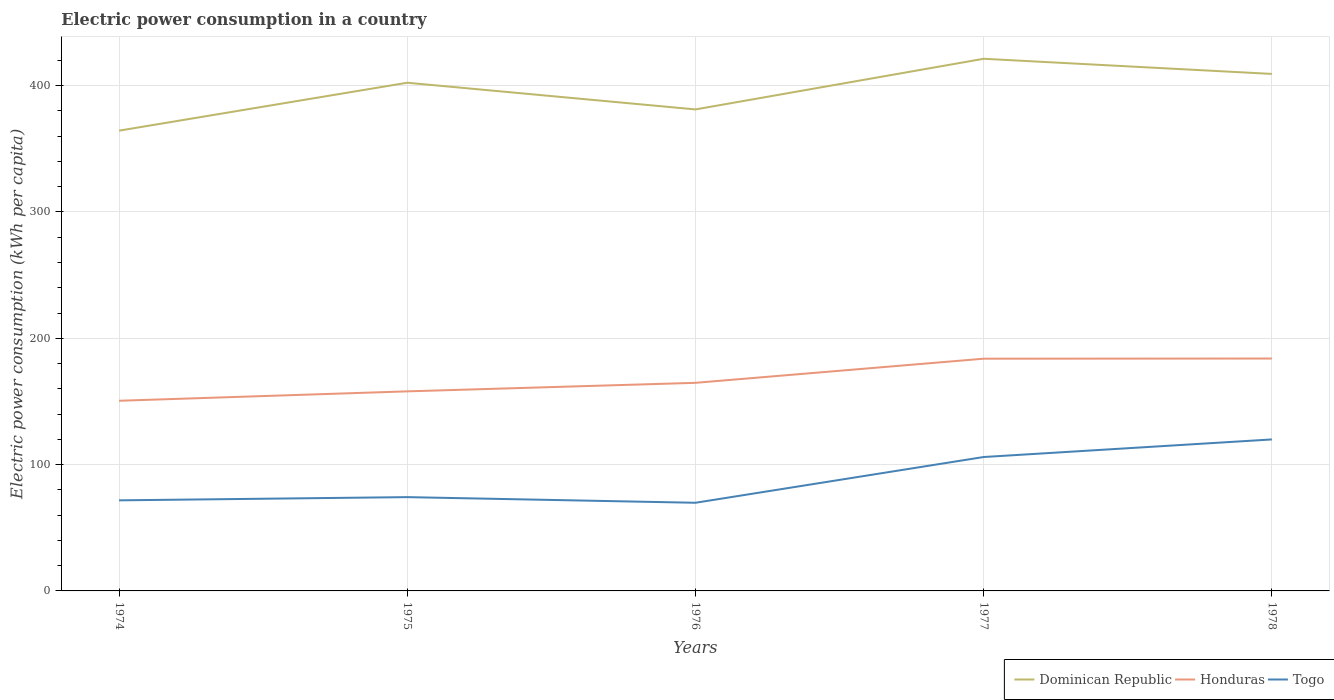How many different coloured lines are there?
Keep it short and to the point. 3. Does the line corresponding to Togo intersect with the line corresponding to Honduras?
Provide a short and direct response. No. Across all years, what is the maximum electric power consumption in in Honduras?
Ensure brevity in your answer.  150.55. In which year was the electric power consumption in in Dominican Republic maximum?
Provide a short and direct response. 1974. What is the total electric power consumption in in Honduras in the graph?
Your response must be concise. -7.44. What is the difference between the highest and the second highest electric power consumption in in Dominican Republic?
Keep it short and to the point. 56.92. How many lines are there?
Provide a succinct answer. 3. How many years are there in the graph?
Your response must be concise. 5. What is the difference between two consecutive major ticks on the Y-axis?
Offer a very short reply. 100. Does the graph contain any zero values?
Ensure brevity in your answer.  No. Does the graph contain grids?
Provide a short and direct response. Yes. How are the legend labels stacked?
Offer a terse response. Horizontal. What is the title of the graph?
Make the answer very short. Electric power consumption in a country. What is the label or title of the Y-axis?
Make the answer very short. Electric power consumption (kWh per capita). What is the Electric power consumption (kWh per capita) of Dominican Republic in 1974?
Your answer should be very brief. 364.38. What is the Electric power consumption (kWh per capita) of Honduras in 1974?
Provide a succinct answer. 150.55. What is the Electric power consumption (kWh per capita) in Togo in 1974?
Make the answer very short. 71.71. What is the Electric power consumption (kWh per capita) in Dominican Republic in 1975?
Provide a short and direct response. 402.34. What is the Electric power consumption (kWh per capita) of Honduras in 1975?
Ensure brevity in your answer.  157.99. What is the Electric power consumption (kWh per capita) in Togo in 1975?
Offer a very short reply. 74.26. What is the Electric power consumption (kWh per capita) of Dominican Republic in 1976?
Give a very brief answer. 381.2. What is the Electric power consumption (kWh per capita) in Honduras in 1976?
Make the answer very short. 164.75. What is the Electric power consumption (kWh per capita) of Togo in 1976?
Provide a succinct answer. 69.79. What is the Electric power consumption (kWh per capita) of Dominican Republic in 1977?
Offer a terse response. 421.3. What is the Electric power consumption (kWh per capita) in Honduras in 1977?
Give a very brief answer. 183.85. What is the Electric power consumption (kWh per capita) in Togo in 1977?
Provide a succinct answer. 106.01. What is the Electric power consumption (kWh per capita) of Dominican Republic in 1978?
Make the answer very short. 409.31. What is the Electric power consumption (kWh per capita) in Honduras in 1978?
Give a very brief answer. 183.98. What is the Electric power consumption (kWh per capita) of Togo in 1978?
Offer a very short reply. 119.93. Across all years, what is the maximum Electric power consumption (kWh per capita) in Dominican Republic?
Provide a succinct answer. 421.3. Across all years, what is the maximum Electric power consumption (kWh per capita) in Honduras?
Your answer should be compact. 183.98. Across all years, what is the maximum Electric power consumption (kWh per capita) in Togo?
Offer a very short reply. 119.93. Across all years, what is the minimum Electric power consumption (kWh per capita) in Dominican Republic?
Give a very brief answer. 364.38. Across all years, what is the minimum Electric power consumption (kWh per capita) of Honduras?
Offer a terse response. 150.55. Across all years, what is the minimum Electric power consumption (kWh per capita) of Togo?
Give a very brief answer. 69.79. What is the total Electric power consumption (kWh per capita) of Dominican Republic in the graph?
Offer a very short reply. 1978.52. What is the total Electric power consumption (kWh per capita) of Honduras in the graph?
Your answer should be compact. 841.12. What is the total Electric power consumption (kWh per capita) of Togo in the graph?
Keep it short and to the point. 441.71. What is the difference between the Electric power consumption (kWh per capita) of Dominican Republic in 1974 and that in 1975?
Make the answer very short. -37.95. What is the difference between the Electric power consumption (kWh per capita) in Honduras in 1974 and that in 1975?
Keep it short and to the point. -7.44. What is the difference between the Electric power consumption (kWh per capita) of Togo in 1974 and that in 1975?
Provide a short and direct response. -2.55. What is the difference between the Electric power consumption (kWh per capita) in Dominican Republic in 1974 and that in 1976?
Offer a terse response. -16.82. What is the difference between the Electric power consumption (kWh per capita) in Honduras in 1974 and that in 1976?
Offer a terse response. -14.2. What is the difference between the Electric power consumption (kWh per capita) of Togo in 1974 and that in 1976?
Give a very brief answer. 1.92. What is the difference between the Electric power consumption (kWh per capita) of Dominican Republic in 1974 and that in 1977?
Offer a very short reply. -56.92. What is the difference between the Electric power consumption (kWh per capita) in Honduras in 1974 and that in 1977?
Give a very brief answer. -33.3. What is the difference between the Electric power consumption (kWh per capita) in Togo in 1974 and that in 1977?
Make the answer very short. -34.3. What is the difference between the Electric power consumption (kWh per capita) in Dominican Republic in 1974 and that in 1978?
Your response must be concise. -44.93. What is the difference between the Electric power consumption (kWh per capita) of Honduras in 1974 and that in 1978?
Your response must be concise. -33.43. What is the difference between the Electric power consumption (kWh per capita) in Togo in 1974 and that in 1978?
Give a very brief answer. -48.22. What is the difference between the Electric power consumption (kWh per capita) of Dominican Republic in 1975 and that in 1976?
Your response must be concise. 21.14. What is the difference between the Electric power consumption (kWh per capita) in Honduras in 1975 and that in 1976?
Give a very brief answer. -6.76. What is the difference between the Electric power consumption (kWh per capita) in Togo in 1975 and that in 1976?
Offer a very short reply. 4.47. What is the difference between the Electric power consumption (kWh per capita) in Dominican Republic in 1975 and that in 1977?
Provide a succinct answer. -18.96. What is the difference between the Electric power consumption (kWh per capita) in Honduras in 1975 and that in 1977?
Give a very brief answer. -25.86. What is the difference between the Electric power consumption (kWh per capita) in Togo in 1975 and that in 1977?
Keep it short and to the point. -31.75. What is the difference between the Electric power consumption (kWh per capita) of Dominican Republic in 1975 and that in 1978?
Keep it short and to the point. -6.97. What is the difference between the Electric power consumption (kWh per capita) in Honduras in 1975 and that in 1978?
Your answer should be very brief. -25.99. What is the difference between the Electric power consumption (kWh per capita) in Togo in 1975 and that in 1978?
Provide a short and direct response. -45.67. What is the difference between the Electric power consumption (kWh per capita) in Dominican Republic in 1976 and that in 1977?
Make the answer very short. -40.1. What is the difference between the Electric power consumption (kWh per capita) of Honduras in 1976 and that in 1977?
Your answer should be very brief. -19.1. What is the difference between the Electric power consumption (kWh per capita) of Togo in 1976 and that in 1977?
Your answer should be compact. -36.22. What is the difference between the Electric power consumption (kWh per capita) in Dominican Republic in 1976 and that in 1978?
Your response must be concise. -28.11. What is the difference between the Electric power consumption (kWh per capita) in Honduras in 1976 and that in 1978?
Offer a very short reply. -19.23. What is the difference between the Electric power consumption (kWh per capita) in Togo in 1976 and that in 1978?
Offer a very short reply. -50.14. What is the difference between the Electric power consumption (kWh per capita) in Dominican Republic in 1977 and that in 1978?
Offer a terse response. 11.99. What is the difference between the Electric power consumption (kWh per capita) of Honduras in 1977 and that in 1978?
Provide a short and direct response. -0.13. What is the difference between the Electric power consumption (kWh per capita) of Togo in 1977 and that in 1978?
Make the answer very short. -13.92. What is the difference between the Electric power consumption (kWh per capita) of Dominican Republic in 1974 and the Electric power consumption (kWh per capita) of Honduras in 1975?
Your answer should be compact. 206.39. What is the difference between the Electric power consumption (kWh per capita) in Dominican Republic in 1974 and the Electric power consumption (kWh per capita) in Togo in 1975?
Offer a terse response. 290.12. What is the difference between the Electric power consumption (kWh per capita) of Honduras in 1974 and the Electric power consumption (kWh per capita) of Togo in 1975?
Offer a terse response. 76.29. What is the difference between the Electric power consumption (kWh per capita) of Dominican Republic in 1974 and the Electric power consumption (kWh per capita) of Honduras in 1976?
Your response must be concise. 199.63. What is the difference between the Electric power consumption (kWh per capita) of Dominican Republic in 1974 and the Electric power consumption (kWh per capita) of Togo in 1976?
Keep it short and to the point. 294.59. What is the difference between the Electric power consumption (kWh per capita) of Honduras in 1974 and the Electric power consumption (kWh per capita) of Togo in 1976?
Your response must be concise. 80.76. What is the difference between the Electric power consumption (kWh per capita) in Dominican Republic in 1974 and the Electric power consumption (kWh per capita) in Honduras in 1977?
Your answer should be very brief. 180.53. What is the difference between the Electric power consumption (kWh per capita) in Dominican Republic in 1974 and the Electric power consumption (kWh per capita) in Togo in 1977?
Your answer should be very brief. 258.37. What is the difference between the Electric power consumption (kWh per capita) of Honduras in 1974 and the Electric power consumption (kWh per capita) of Togo in 1977?
Your answer should be compact. 44.54. What is the difference between the Electric power consumption (kWh per capita) in Dominican Republic in 1974 and the Electric power consumption (kWh per capita) in Honduras in 1978?
Provide a short and direct response. 180.4. What is the difference between the Electric power consumption (kWh per capita) in Dominican Republic in 1974 and the Electric power consumption (kWh per capita) in Togo in 1978?
Your answer should be compact. 244.45. What is the difference between the Electric power consumption (kWh per capita) in Honduras in 1974 and the Electric power consumption (kWh per capita) in Togo in 1978?
Offer a terse response. 30.62. What is the difference between the Electric power consumption (kWh per capita) of Dominican Republic in 1975 and the Electric power consumption (kWh per capita) of Honduras in 1976?
Your answer should be compact. 237.59. What is the difference between the Electric power consumption (kWh per capita) in Dominican Republic in 1975 and the Electric power consumption (kWh per capita) in Togo in 1976?
Offer a terse response. 332.54. What is the difference between the Electric power consumption (kWh per capita) in Honduras in 1975 and the Electric power consumption (kWh per capita) in Togo in 1976?
Offer a terse response. 88.2. What is the difference between the Electric power consumption (kWh per capita) of Dominican Republic in 1975 and the Electric power consumption (kWh per capita) of Honduras in 1977?
Ensure brevity in your answer.  218.48. What is the difference between the Electric power consumption (kWh per capita) in Dominican Republic in 1975 and the Electric power consumption (kWh per capita) in Togo in 1977?
Give a very brief answer. 296.32. What is the difference between the Electric power consumption (kWh per capita) of Honduras in 1975 and the Electric power consumption (kWh per capita) of Togo in 1977?
Provide a succinct answer. 51.98. What is the difference between the Electric power consumption (kWh per capita) of Dominican Republic in 1975 and the Electric power consumption (kWh per capita) of Honduras in 1978?
Provide a short and direct response. 218.36. What is the difference between the Electric power consumption (kWh per capita) of Dominican Republic in 1975 and the Electric power consumption (kWh per capita) of Togo in 1978?
Provide a succinct answer. 282.4. What is the difference between the Electric power consumption (kWh per capita) in Honduras in 1975 and the Electric power consumption (kWh per capita) in Togo in 1978?
Offer a very short reply. 38.06. What is the difference between the Electric power consumption (kWh per capita) of Dominican Republic in 1976 and the Electric power consumption (kWh per capita) of Honduras in 1977?
Give a very brief answer. 197.34. What is the difference between the Electric power consumption (kWh per capita) of Dominican Republic in 1976 and the Electric power consumption (kWh per capita) of Togo in 1977?
Your answer should be compact. 275.18. What is the difference between the Electric power consumption (kWh per capita) in Honduras in 1976 and the Electric power consumption (kWh per capita) in Togo in 1977?
Offer a terse response. 58.74. What is the difference between the Electric power consumption (kWh per capita) in Dominican Republic in 1976 and the Electric power consumption (kWh per capita) in Honduras in 1978?
Your response must be concise. 197.22. What is the difference between the Electric power consumption (kWh per capita) of Dominican Republic in 1976 and the Electric power consumption (kWh per capita) of Togo in 1978?
Your answer should be compact. 261.27. What is the difference between the Electric power consumption (kWh per capita) in Honduras in 1976 and the Electric power consumption (kWh per capita) in Togo in 1978?
Your answer should be compact. 44.82. What is the difference between the Electric power consumption (kWh per capita) in Dominican Republic in 1977 and the Electric power consumption (kWh per capita) in Honduras in 1978?
Ensure brevity in your answer.  237.32. What is the difference between the Electric power consumption (kWh per capita) of Dominican Republic in 1977 and the Electric power consumption (kWh per capita) of Togo in 1978?
Offer a very short reply. 301.36. What is the difference between the Electric power consumption (kWh per capita) of Honduras in 1977 and the Electric power consumption (kWh per capita) of Togo in 1978?
Ensure brevity in your answer.  63.92. What is the average Electric power consumption (kWh per capita) in Dominican Republic per year?
Provide a succinct answer. 395.7. What is the average Electric power consumption (kWh per capita) of Honduras per year?
Provide a succinct answer. 168.22. What is the average Electric power consumption (kWh per capita) of Togo per year?
Your answer should be very brief. 88.34. In the year 1974, what is the difference between the Electric power consumption (kWh per capita) of Dominican Republic and Electric power consumption (kWh per capita) of Honduras?
Provide a short and direct response. 213.83. In the year 1974, what is the difference between the Electric power consumption (kWh per capita) in Dominican Republic and Electric power consumption (kWh per capita) in Togo?
Provide a short and direct response. 292.67. In the year 1974, what is the difference between the Electric power consumption (kWh per capita) of Honduras and Electric power consumption (kWh per capita) of Togo?
Give a very brief answer. 78.84. In the year 1975, what is the difference between the Electric power consumption (kWh per capita) of Dominican Republic and Electric power consumption (kWh per capita) of Honduras?
Your answer should be very brief. 244.34. In the year 1975, what is the difference between the Electric power consumption (kWh per capita) of Dominican Republic and Electric power consumption (kWh per capita) of Togo?
Ensure brevity in your answer.  328.08. In the year 1975, what is the difference between the Electric power consumption (kWh per capita) in Honduras and Electric power consumption (kWh per capita) in Togo?
Provide a short and direct response. 83.73. In the year 1976, what is the difference between the Electric power consumption (kWh per capita) in Dominican Republic and Electric power consumption (kWh per capita) in Honduras?
Your answer should be compact. 216.45. In the year 1976, what is the difference between the Electric power consumption (kWh per capita) in Dominican Republic and Electric power consumption (kWh per capita) in Togo?
Keep it short and to the point. 311.41. In the year 1976, what is the difference between the Electric power consumption (kWh per capita) of Honduras and Electric power consumption (kWh per capita) of Togo?
Your answer should be compact. 94.96. In the year 1977, what is the difference between the Electric power consumption (kWh per capita) in Dominican Republic and Electric power consumption (kWh per capita) in Honduras?
Keep it short and to the point. 237.44. In the year 1977, what is the difference between the Electric power consumption (kWh per capita) in Dominican Republic and Electric power consumption (kWh per capita) in Togo?
Your answer should be very brief. 315.28. In the year 1977, what is the difference between the Electric power consumption (kWh per capita) in Honduras and Electric power consumption (kWh per capita) in Togo?
Provide a short and direct response. 77.84. In the year 1978, what is the difference between the Electric power consumption (kWh per capita) of Dominican Republic and Electric power consumption (kWh per capita) of Honduras?
Your answer should be compact. 225.33. In the year 1978, what is the difference between the Electric power consumption (kWh per capita) in Dominican Republic and Electric power consumption (kWh per capita) in Togo?
Your answer should be very brief. 289.38. In the year 1978, what is the difference between the Electric power consumption (kWh per capita) in Honduras and Electric power consumption (kWh per capita) in Togo?
Your response must be concise. 64.05. What is the ratio of the Electric power consumption (kWh per capita) of Dominican Republic in 1974 to that in 1975?
Provide a short and direct response. 0.91. What is the ratio of the Electric power consumption (kWh per capita) in Honduras in 1974 to that in 1975?
Provide a short and direct response. 0.95. What is the ratio of the Electric power consumption (kWh per capita) of Togo in 1974 to that in 1975?
Make the answer very short. 0.97. What is the ratio of the Electric power consumption (kWh per capita) of Dominican Republic in 1974 to that in 1976?
Your answer should be very brief. 0.96. What is the ratio of the Electric power consumption (kWh per capita) of Honduras in 1974 to that in 1976?
Make the answer very short. 0.91. What is the ratio of the Electric power consumption (kWh per capita) in Togo in 1974 to that in 1976?
Your answer should be very brief. 1.03. What is the ratio of the Electric power consumption (kWh per capita) in Dominican Republic in 1974 to that in 1977?
Offer a terse response. 0.86. What is the ratio of the Electric power consumption (kWh per capita) of Honduras in 1974 to that in 1977?
Your answer should be very brief. 0.82. What is the ratio of the Electric power consumption (kWh per capita) in Togo in 1974 to that in 1977?
Provide a succinct answer. 0.68. What is the ratio of the Electric power consumption (kWh per capita) of Dominican Republic in 1974 to that in 1978?
Your answer should be very brief. 0.89. What is the ratio of the Electric power consumption (kWh per capita) of Honduras in 1974 to that in 1978?
Ensure brevity in your answer.  0.82. What is the ratio of the Electric power consumption (kWh per capita) of Togo in 1974 to that in 1978?
Make the answer very short. 0.6. What is the ratio of the Electric power consumption (kWh per capita) of Dominican Republic in 1975 to that in 1976?
Provide a succinct answer. 1.06. What is the ratio of the Electric power consumption (kWh per capita) in Honduras in 1975 to that in 1976?
Your answer should be very brief. 0.96. What is the ratio of the Electric power consumption (kWh per capita) of Togo in 1975 to that in 1976?
Offer a terse response. 1.06. What is the ratio of the Electric power consumption (kWh per capita) in Dominican Republic in 1975 to that in 1977?
Ensure brevity in your answer.  0.95. What is the ratio of the Electric power consumption (kWh per capita) of Honduras in 1975 to that in 1977?
Offer a very short reply. 0.86. What is the ratio of the Electric power consumption (kWh per capita) of Togo in 1975 to that in 1977?
Give a very brief answer. 0.7. What is the ratio of the Electric power consumption (kWh per capita) in Dominican Republic in 1975 to that in 1978?
Make the answer very short. 0.98. What is the ratio of the Electric power consumption (kWh per capita) of Honduras in 1975 to that in 1978?
Provide a short and direct response. 0.86. What is the ratio of the Electric power consumption (kWh per capita) of Togo in 1975 to that in 1978?
Your answer should be very brief. 0.62. What is the ratio of the Electric power consumption (kWh per capita) in Dominican Republic in 1976 to that in 1977?
Make the answer very short. 0.9. What is the ratio of the Electric power consumption (kWh per capita) in Honduras in 1976 to that in 1977?
Keep it short and to the point. 0.9. What is the ratio of the Electric power consumption (kWh per capita) of Togo in 1976 to that in 1977?
Provide a short and direct response. 0.66. What is the ratio of the Electric power consumption (kWh per capita) in Dominican Republic in 1976 to that in 1978?
Your answer should be very brief. 0.93. What is the ratio of the Electric power consumption (kWh per capita) in Honduras in 1976 to that in 1978?
Offer a terse response. 0.9. What is the ratio of the Electric power consumption (kWh per capita) of Togo in 1976 to that in 1978?
Offer a terse response. 0.58. What is the ratio of the Electric power consumption (kWh per capita) in Dominican Republic in 1977 to that in 1978?
Your response must be concise. 1.03. What is the ratio of the Electric power consumption (kWh per capita) of Togo in 1977 to that in 1978?
Make the answer very short. 0.88. What is the difference between the highest and the second highest Electric power consumption (kWh per capita) of Dominican Republic?
Your answer should be very brief. 11.99. What is the difference between the highest and the second highest Electric power consumption (kWh per capita) in Honduras?
Make the answer very short. 0.13. What is the difference between the highest and the second highest Electric power consumption (kWh per capita) of Togo?
Your answer should be very brief. 13.92. What is the difference between the highest and the lowest Electric power consumption (kWh per capita) in Dominican Republic?
Offer a very short reply. 56.92. What is the difference between the highest and the lowest Electric power consumption (kWh per capita) of Honduras?
Ensure brevity in your answer.  33.43. What is the difference between the highest and the lowest Electric power consumption (kWh per capita) of Togo?
Keep it short and to the point. 50.14. 